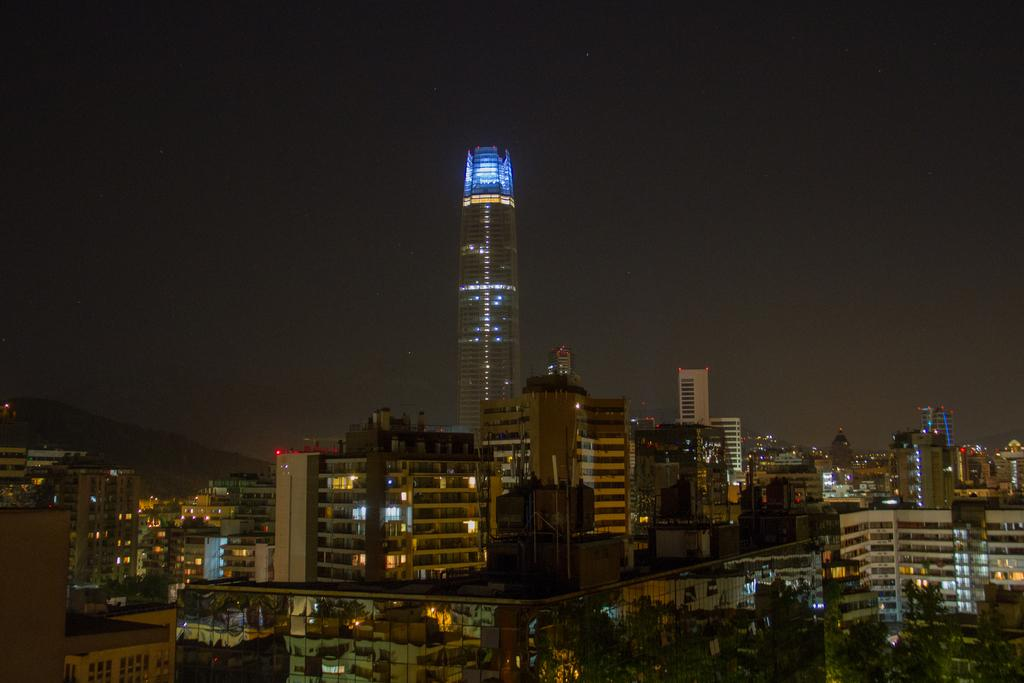What type of structures can be seen in the image? There are buildings and a tower in the image. What other natural elements are present in the image? There are trees in the image. Are there any artificial light sources visible in the image? Yes, there are lights in the image. How would you describe the appearance of the sky in the image? The sky appears to be pale and dark in the image. Can you tell me how many times the bomb exploded in the image? There is no bomb present in the image, so it cannot be determined how many times it exploded. 